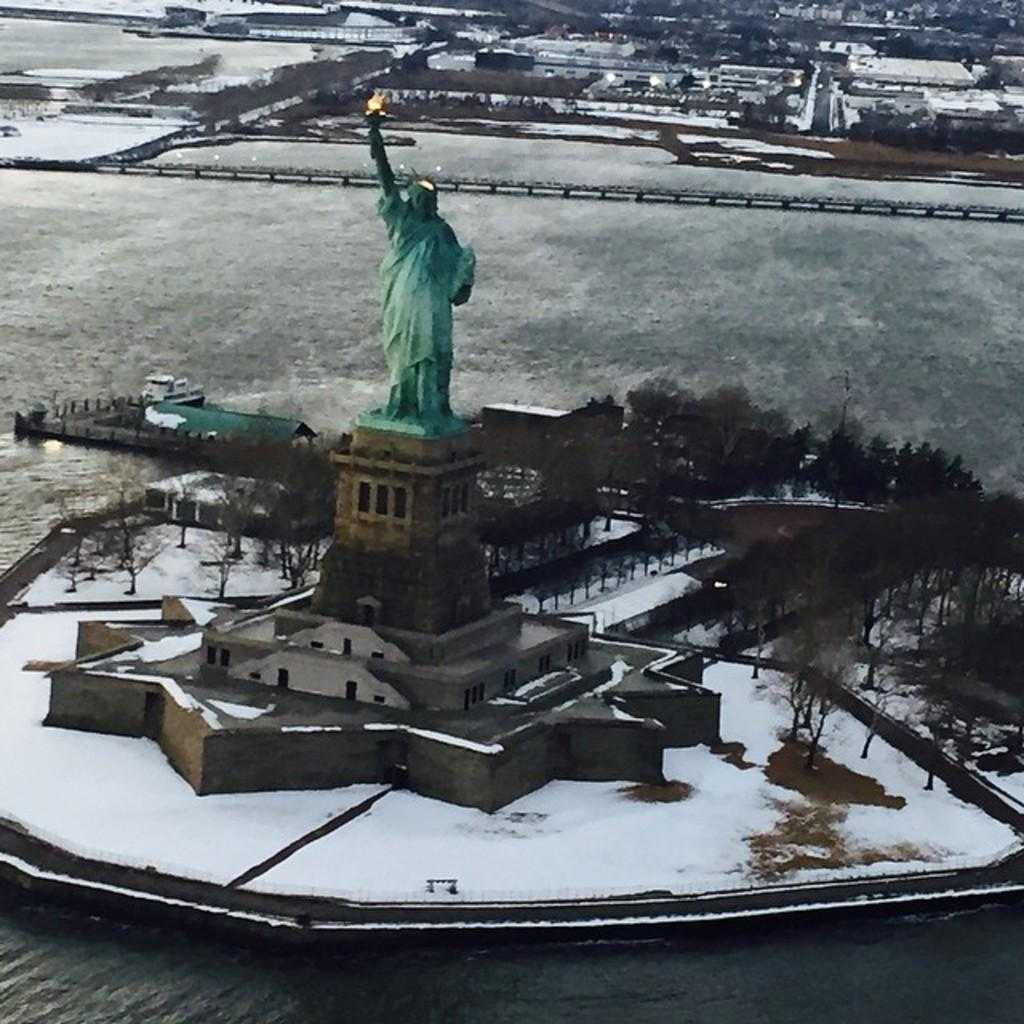What is the main subject of the image? There is a statue in the image. Where is the statue located? The statue is on a building. What can be seen behind the statue? There are trees behind the statue. What is the setting of the statue? The statue is in the middle of the sea. What type of vegetation is visible in the background of the image? There are trees visible in the background of the image. Can you see the statue's hand stretching out to touch the shoe in the image? There is no shoe present in the image, and the statue's hand is not shown stretching out. 